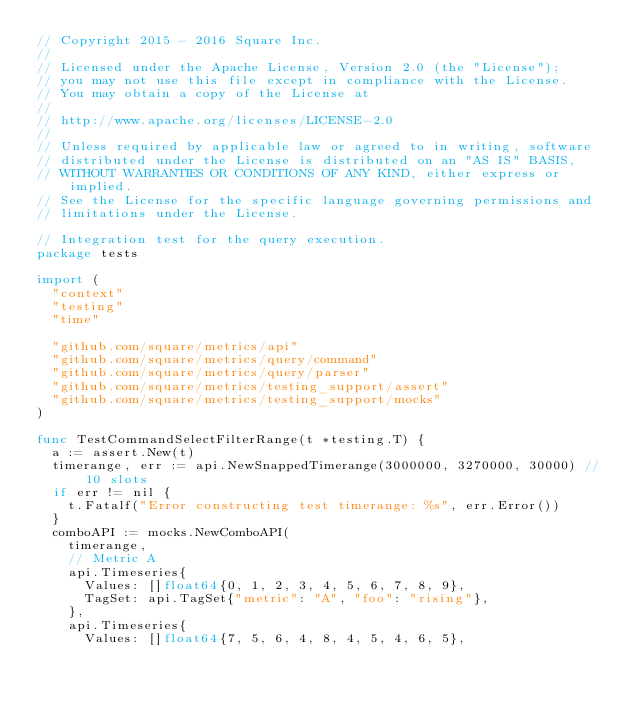<code> <loc_0><loc_0><loc_500><loc_500><_Go_>// Copyright 2015 - 2016 Square Inc.
//
// Licensed under the Apache License, Version 2.0 (the "License");
// you may not use this file except in compliance with the License.
// You may obtain a copy of the License at
//
// http://www.apache.org/licenses/LICENSE-2.0
//
// Unless required by applicable law or agreed to in writing, software
// distributed under the License is distributed on an "AS IS" BASIS,
// WITHOUT WARRANTIES OR CONDITIONS OF ANY KIND, either express or implied.
// See the License for the specific language governing permissions and
// limitations under the License.

// Integration test for the query execution.
package tests

import (
	"context"
	"testing"
	"time"

	"github.com/square/metrics/api"
	"github.com/square/metrics/query/command"
	"github.com/square/metrics/query/parser"
	"github.com/square/metrics/testing_support/assert"
	"github.com/square/metrics/testing_support/mocks"
)

func TestCommandSelectFilterRange(t *testing.T) {
	a := assert.New(t)
	timerange, err := api.NewSnappedTimerange(3000000, 3270000, 30000) // 10 slots
	if err != nil {
		t.Fatalf("Error constructing test timerange: %s", err.Error())
	}
	comboAPI := mocks.NewComboAPI(
		timerange,
		// Metric A
		api.Timeseries{
			Values: []float64{0, 1, 2, 3, 4, 5, 6, 7, 8, 9},
			TagSet: api.TagSet{"metric": "A", "foo": "rising"},
		},
		api.Timeseries{
			Values: []float64{7, 5, 6, 4, 8, 4, 5, 4, 6, 5},</code> 